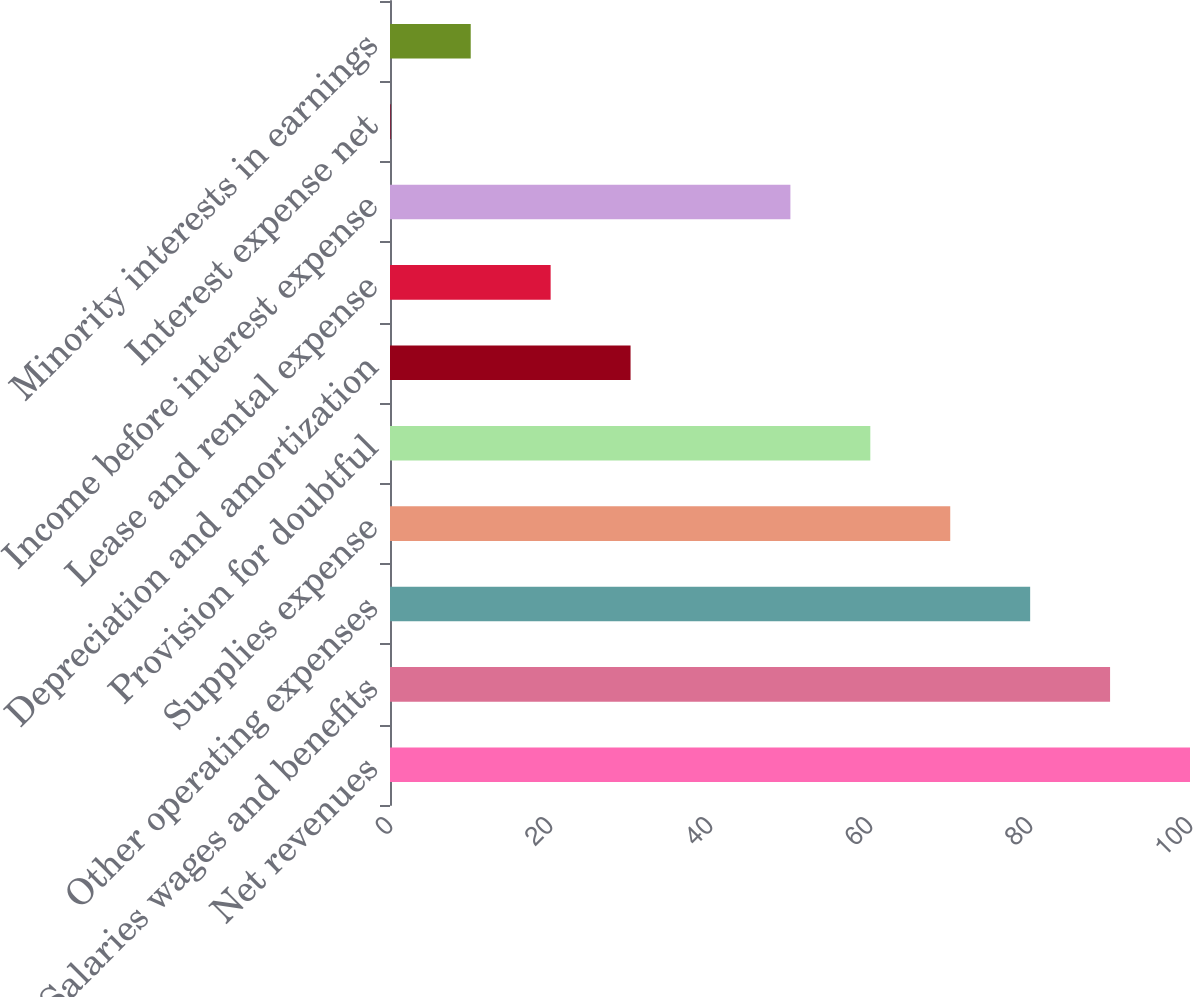<chart> <loc_0><loc_0><loc_500><loc_500><bar_chart><fcel>Net revenues<fcel>Salaries wages and benefits<fcel>Other operating expenses<fcel>Supplies expense<fcel>Provision for doubtful<fcel>Depreciation and amortization<fcel>Lease and rental expense<fcel>Income before interest expense<fcel>Interest expense net<fcel>Minority interests in earnings<nl><fcel>100<fcel>90.01<fcel>80.02<fcel>70.03<fcel>60.04<fcel>30.07<fcel>20.08<fcel>50.05<fcel>0.1<fcel>10.09<nl></chart> 